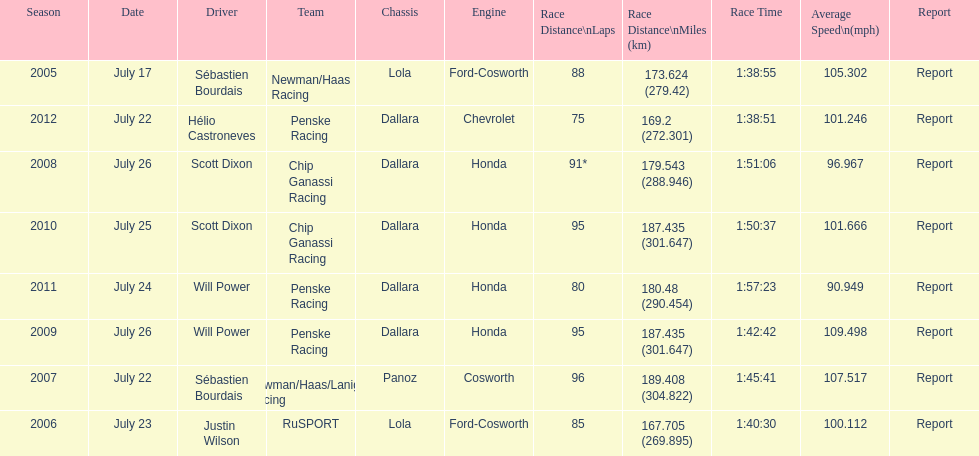How many times did sébastien bourdais win the champ car world series between 2005 and 2007? 2. 